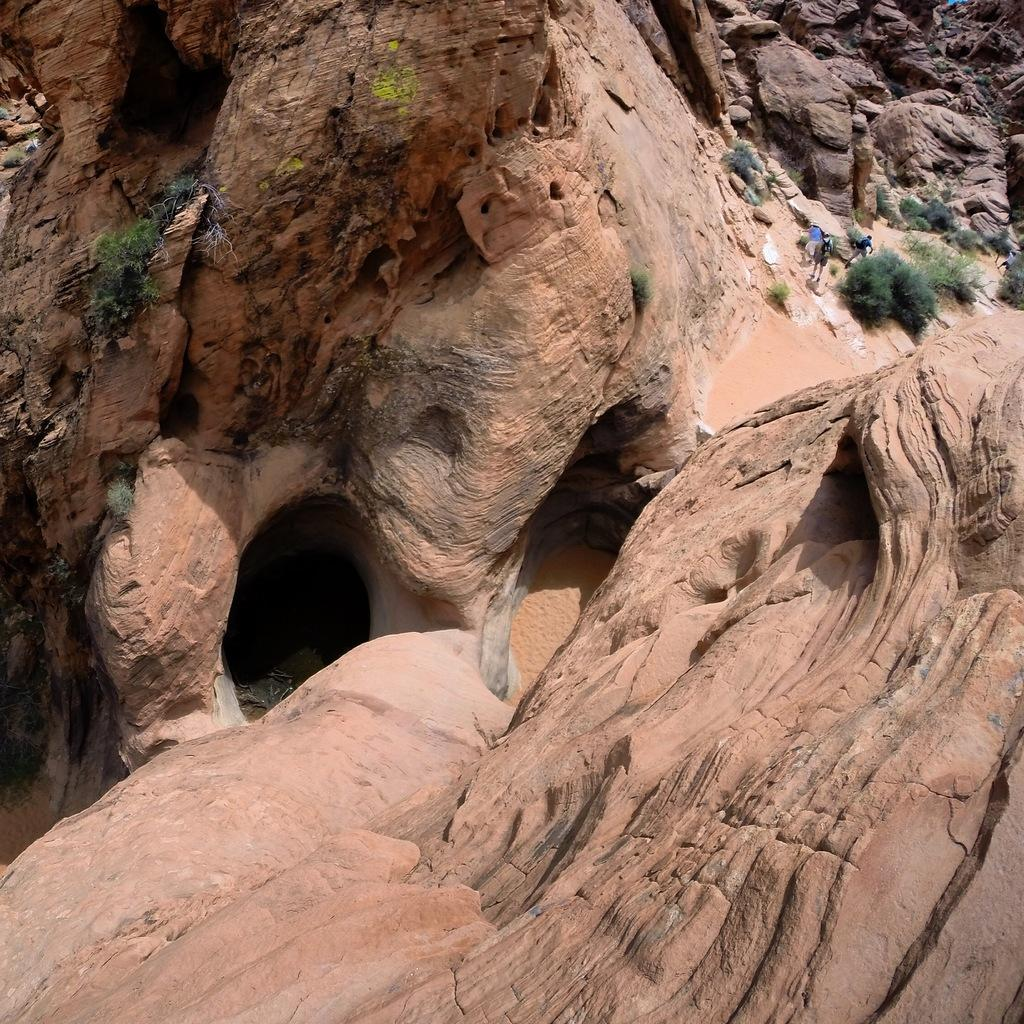What type of natural formation can be seen in the image? There are rocks in the image. What is growing on the rocks? There are plants on the rocks. Where is the person located in the image? The person is on the right side of the image. What other living creature is present on the right side of the image? There is an animal on the right side of the image. What type of property is being sold in the image? There is no indication of a property being sold in the image; it features rocks, plants, a person, and an animal. What error can be corrected in the image? There is no error present in the image; it accurately depicts rocks, plants, a person, and an animal. 